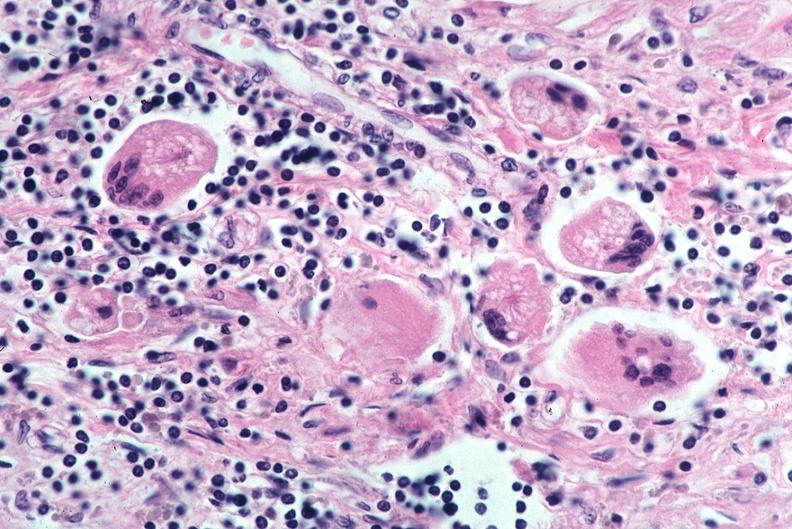what is present?
Answer the question using a single word or phrase. Respiratory 